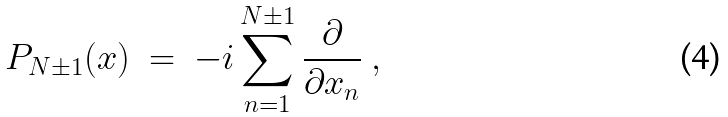Convert formula to latex. <formula><loc_0><loc_0><loc_500><loc_500>P _ { N \pm 1 } ( { x } ) \ = \ - i \sum _ { n = 1 } ^ { N \pm 1 } \frac { \partial } { \partial x _ { n } } \ ,</formula> 